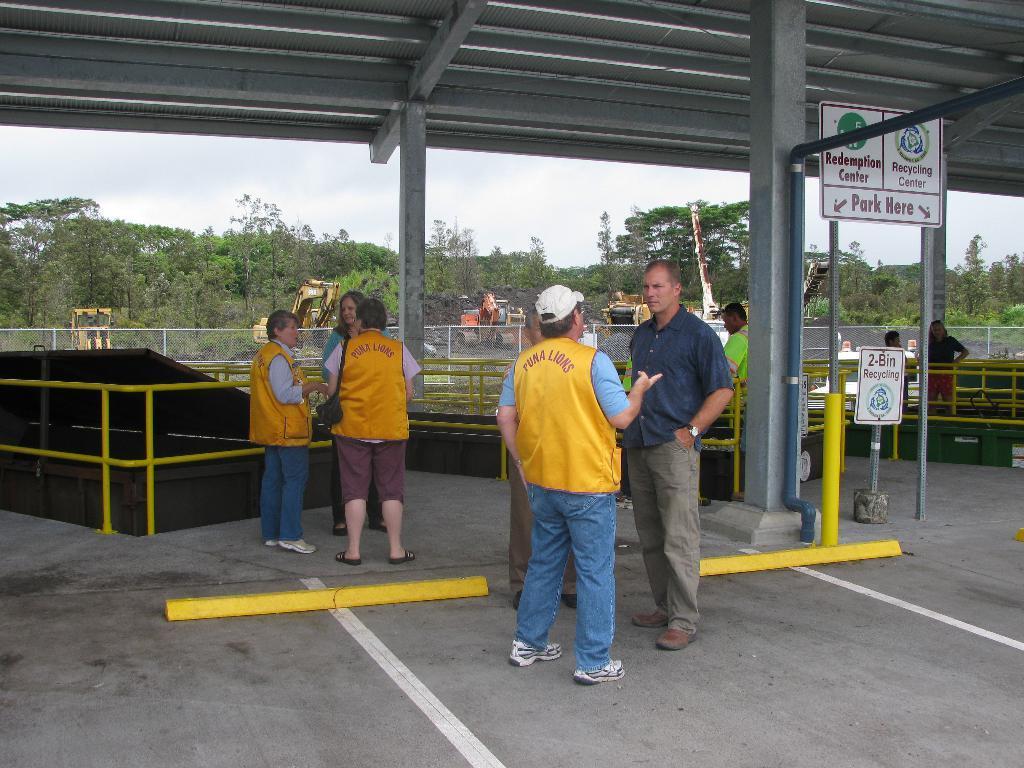Please provide a concise description of this image. In this image there are group of persons standing. On the right side there is a board with some text written on it. In the background there are railings and trees and there are vehicles. 